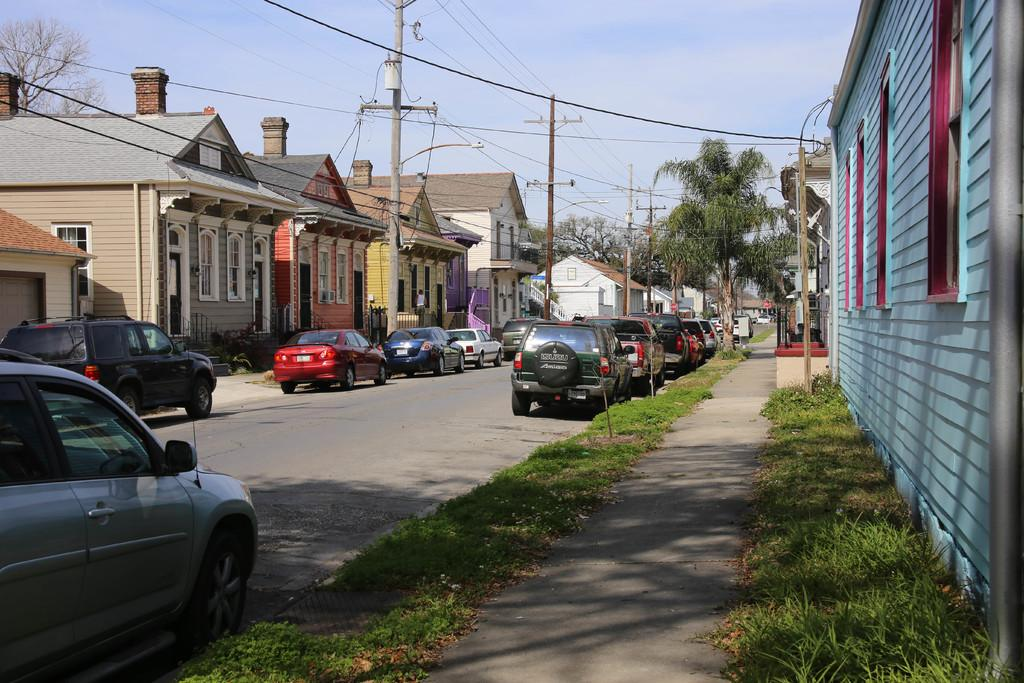What type of vehicles can be seen in the image? There are cars in the image. What type of vegetation is present in the image? There is grass and trees in the image. What type of residential structures are visible in the image? There are current polls houses in the image. What part of the natural environment is visible in the image? The sky is visible in the image. What type of advertisement can be seen on the cars in the image? There is no advertisement visible on the cars in the image. What sound might the alarm make in the image? There is no alarm present in the image, so it is not possible to determine what sound it might make. 